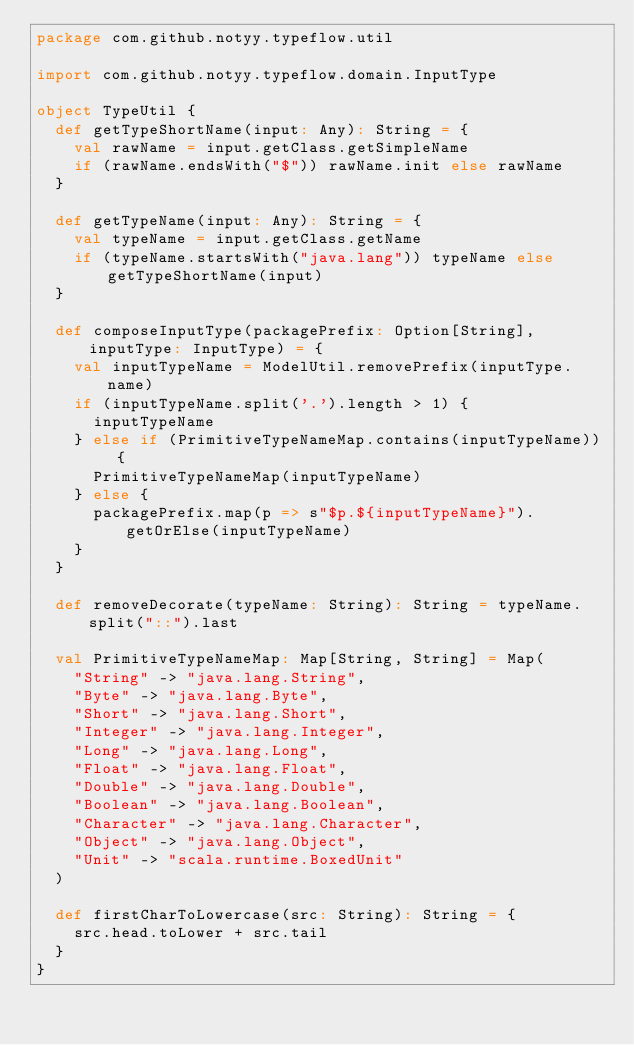<code> <loc_0><loc_0><loc_500><loc_500><_Scala_>package com.github.notyy.typeflow.util

import com.github.notyy.typeflow.domain.InputType

object TypeUtil {
  def getTypeShortName(input: Any): String = {
    val rawName = input.getClass.getSimpleName
    if (rawName.endsWith("$")) rawName.init else rawName
  }

  def getTypeName(input: Any): String = {
    val typeName = input.getClass.getName
    if (typeName.startsWith("java.lang")) typeName else getTypeShortName(input)
  }

  def composeInputType(packagePrefix: Option[String], inputType: InputType) = {
    val inputTypeName = ModelUtil.removePrefix(inputType.name)
    if (inputTypeName.split('.').length > 1) {
      inputTypeName
    } else if (PrimitiveTypeNameMap.contains(inputTypeName)) {
      PrimitiveTypeNameMap(inputTypeName)
    } else {
      packagePrefix.map(p => s"$p.${inputTypeName}").getOrElse(inputTypeName)
    }
  }

  def removeDecorate(typeName: String): String = typeName.split("::").last

  val PrimitiveTypeNameMap: Map[String, String] = Map(
    "String" -> "java.lang.String",
    "Byte" -> "java.lang.Byte",
    "Short" -> "java.lang.Short",
    "Integer" -> "java.lang.Integer",
    "Long" -> "java.lang.Long",
    "Float" -> "java.lang.Float",
    "Double" -> "java.lang.Double",
    "Boolean" -> "java.lang.Boolean",
    "Character" -> "java.lang.Character",
    "Object" -> "java.lang.Object",
    "Unit" -> "scala.runtime.BoxedUnit"
  )

  def firstCharToLowercase(src: String): String = {
    src.head.toLower + src.tail
  }
}
</code> 